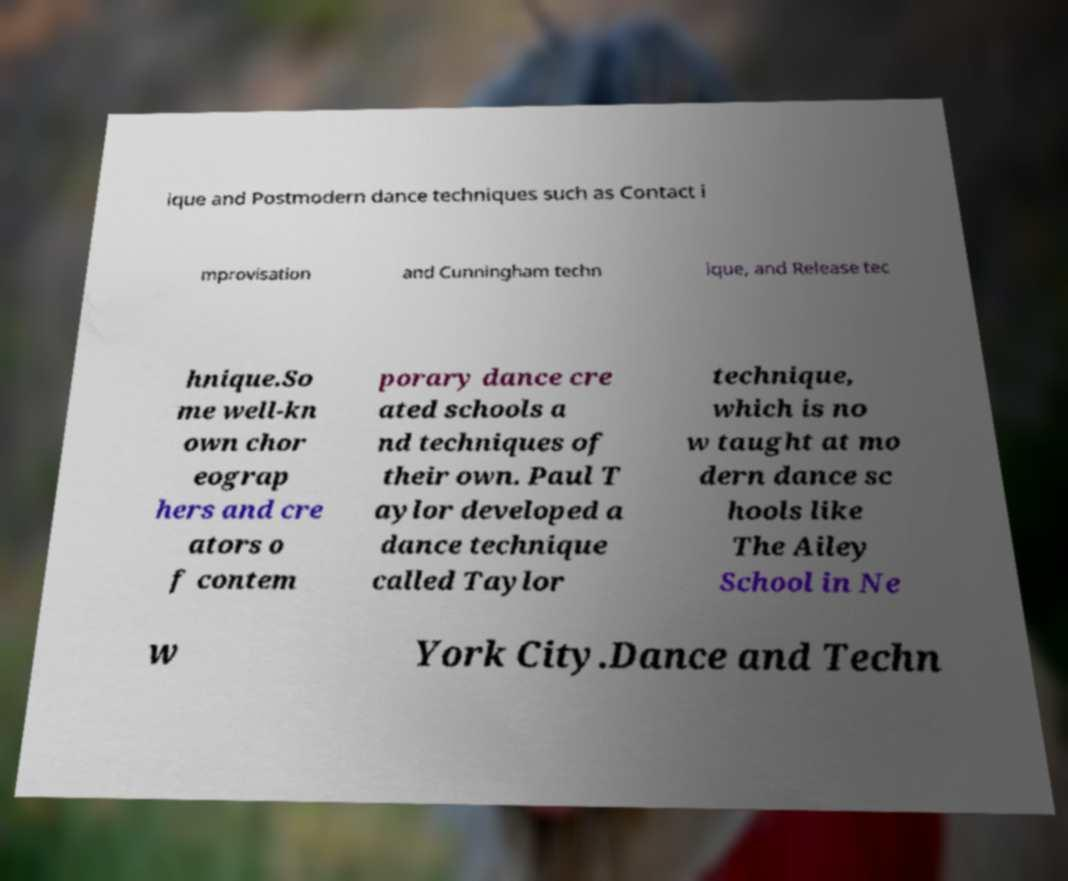Can you read and provide the text displayed in the image?This photo seems to have some interesting text. Can you extract and type it out for me? ique and Postmodern dance techniques such as Contact i mprovisation and Cunningham techn ique, and Release tec hnique.So me well-kn own chor eograp hers and cre ators o f contem porary dance cre ated schools a nd techniques of their own. Paul T aylor developed a dance technique called Taylor technique, which is no w taught at mo dern dance sc hools like The Ailey School in Ne w York City.Dance and Techn 